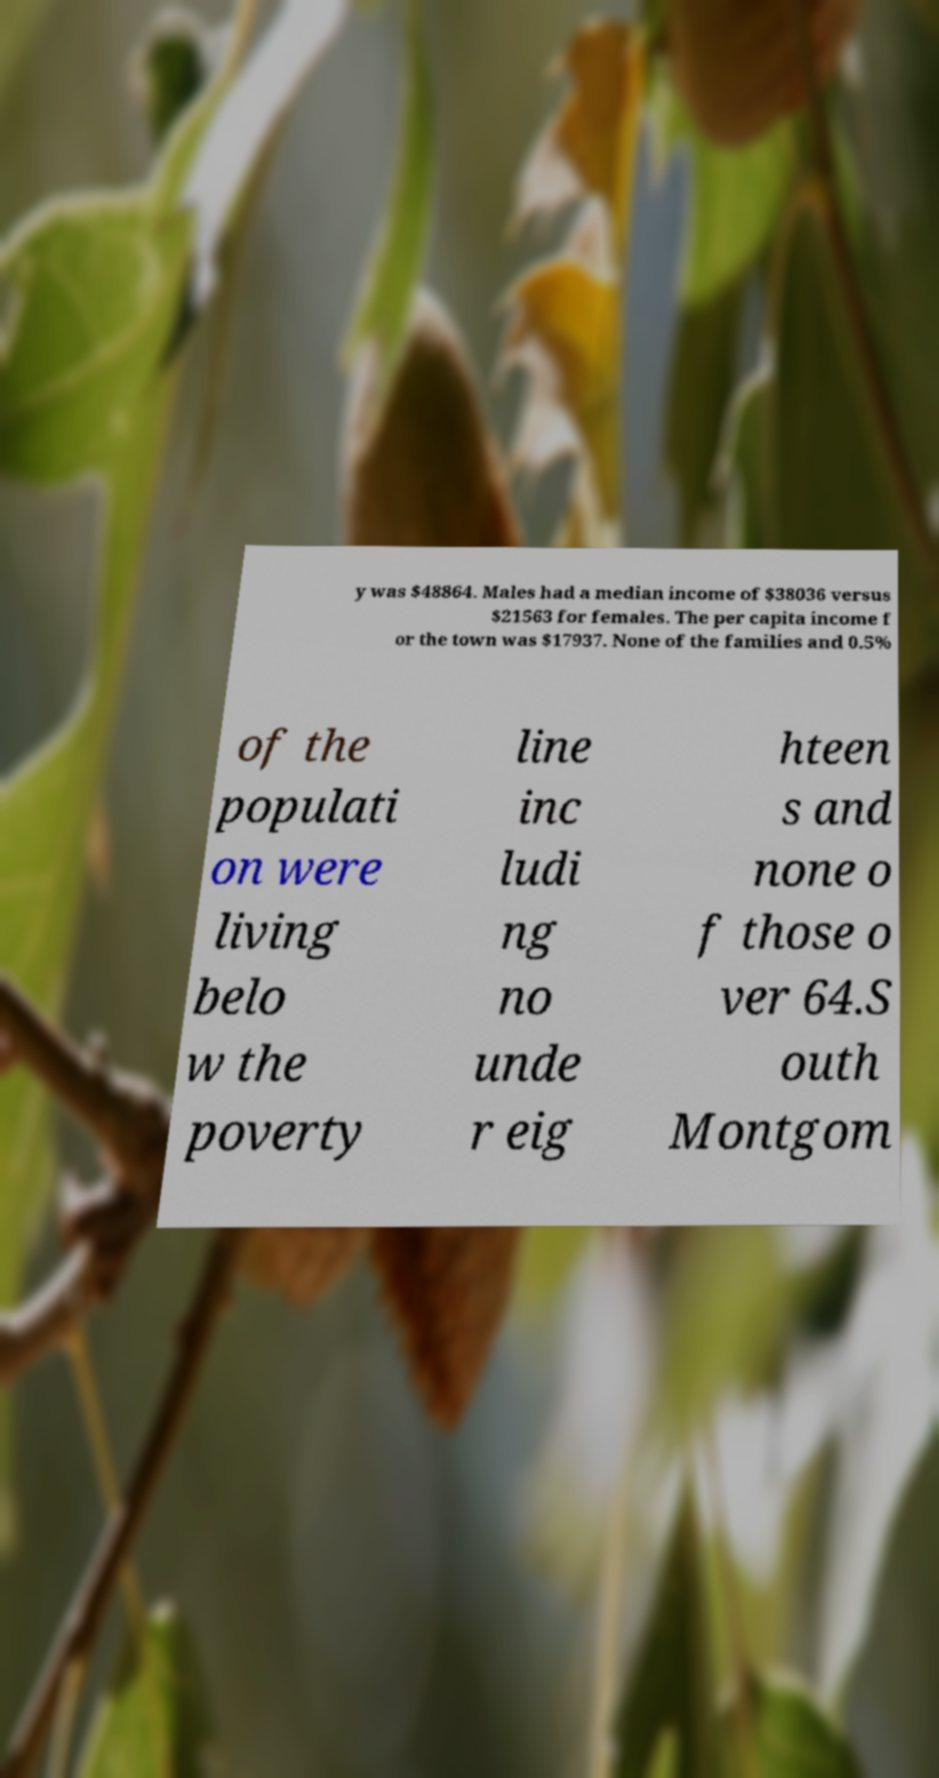For documentation purposes, I need the text within this image transcribed. Could you provide that? y was $48864. Males had a median income of $38036 versus $21563 for females. The per capita income f or the town was $17937. None of the families and 0.5% of the populati on were living belo w the poverty line inc ludi ng no unde r eig hteen s and none o f those o ver 64.S outh Montgom 